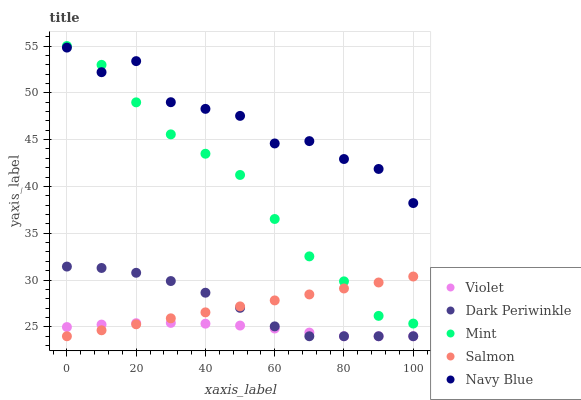Does Violet have the minimum area under the curve?
Answer yes or no. Yes. Does Navy Blue have the maximum area under the curve?
Answer yes or no. Yes. Does Mint have the minimum area under the curve?
Answer yes or no. No. Does Mint have the maximum area under the curve?
Answer yes or no. No. Is Salmon the smoothest?
Answer yes or no. Yes. Is Navy Blue the roughest?
Answer yes or no. Yes. Is Mint the smoothest?
Answer yes or no. No. Is Mint the roughest?
Answer yes or no. No. Does Salmon have the lowest value?
Answer yes or no. Yes. Does Mint have the lowest value?
Answer yes or no. No. Does Mint have the highest value?
Answer yes or no. Yes. Does Navy Blue have the highest value?
Answer yes or no. No. Is Violet less than Navy Blue?
Answer yes or no. Yes. Is Mint greater than Dark Periwinkle?
Answer yes or no. Yes. Does Salmon intersect Dark Periwinkle?
Answer yes or no. Yes. Is Salmon less than Dark Periwinkle?
Answer yes or no. No. Is Salmon greater than Dark Periwinkle?
Answer yes or no. No. Does Violet intersect Navy Blue?
Answer yes or no. No. 